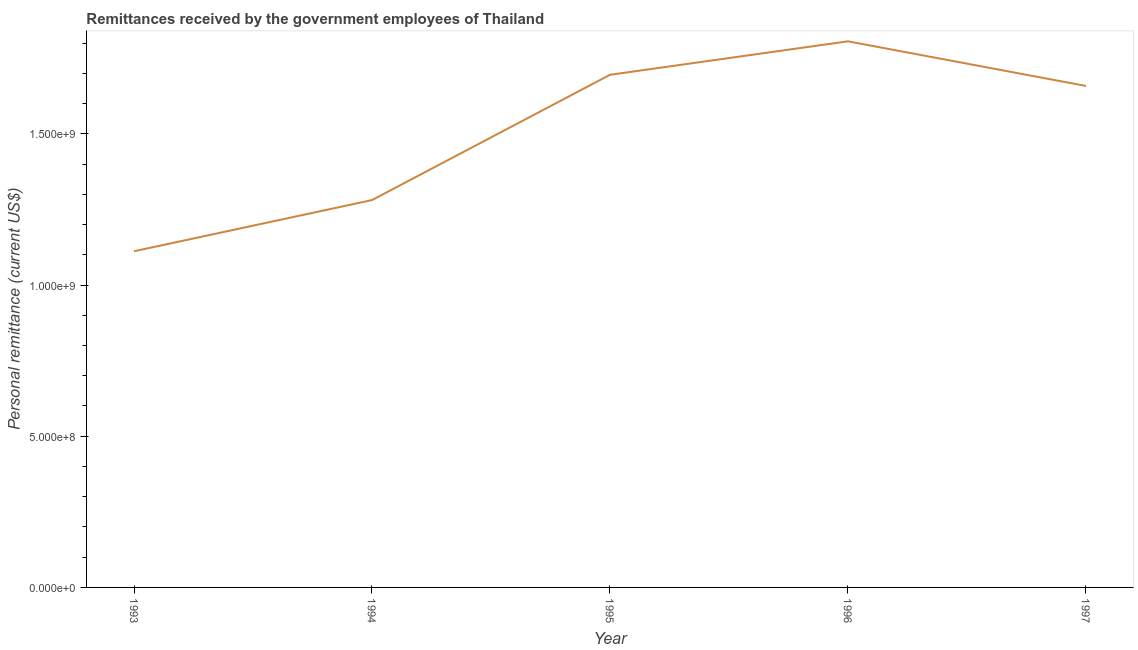What is the personal remittances in 1993?
Give a very brief answer. 1.11e+09. Across all years, what is the maximum personal remittances?
Keep it short and to the point. 1.81e+09. Across all years, what is the minimum personal remittances?
Provide a short and direct response. 1.11e+09. What is the sum of the personal remittances?
Keep it short and to the point. 7.55e+09. What is the difference between the personal remittances in 1994 and 1997?
Ensure brevity in your answer.  -3.77e+08. What is the average personal remittances per year?
Your answer should be very brief. 1.51e+09. What is the median personal remittances?
Give a very brief answer. 1.66e+09. In how many years, is the personal remittances greater than 700000000 US$?
Offer a very short reply. 5. What is the ratio of the personal remittances in 1995 to that in 1996?
Provide a succinct answer. 0.94. What is the difference between the highest and the second highest personal remittances?
Your answer should be very brief. 1.11e+08. Is the sum of the personal remittances in 1996 and 1997 greater than the maximum personal remittances across all years?
Your answer should be very brief. Yes. What is the difference between the highest and the lowest personal remittances?
Offer a very short reply. 6.94e+08. Does the personal remittances monotonically increase over the years?
Your answer should be compact. No. How many lines are there?
Your response must be concise. 1. Are the values on the major ticks of Y-axis written in scientific E-notation?
Make the answer very short. Yes. What is the title of the graph?
Your response must be concise. Remittances received by the government employees of Thailand. What is the label or title of the X-axis?
Provide a succinct answer. Year. What is the label or title of the Y-axis?
Offer a terse response. Personal remittance (current US$). What is the Personal remittance (current US$) of 1993?
Provide a short and direct response. 1.11e+09. What is the Personal remittance (current US$) in 1994?
Provide a short and direct response. 1.28e+09. What is the Personal remittance (current US$) of 1995?
Your answer should be compact. 1.70e+09. What is the Personal remittance (current US$) in 1996?
Give a very brief answer. 1.81e+09. What is the Personal remittance (current US$) of 1997?
Offer a terse response. 1.66e+09. What is the difference between the Personal remittance (current US$) in 1993 and 1994?
Ensure brevity in your answer.  -1.69e+08. What is the difference between the Personal remittance (current US$) in 1993 and 1995?
Your answer should be compact. -5.84e+08. What is the difference between the Personal remittance (current US$) in 1993 and 1996?
Provide a short and direct response. -6.94e+08. What is the difference between the Personal remittance (current US$) in 1993 and 1997?
Ensure brevity in your answer.  -5.47e+08. What is the difference between the Personal remittance (current US$) in 1994 and 1995?
Provide a short and direct response. -4.14e+08. What is the difference between the Personal remittance (current US$) in 1994 and 1996?
Keep it short and to the point. -5.25e+08. What is the difference between the Personal remittance (current US$) in 1994 and 1997?
Your answer should be very brief. -3.77e+08. What is the difference between the Personal remittance (current US$) in 1995 and 1996?
Make the answer very short. -1.11e+08. What is the difference between the Personal remittance (current US$) in 1995 and 1997?
Your response must be concise. 3.69e+07. What is the difference between the Personal remittance (current US$) in 1996 and 1997?
Your answer should be compact. 1.48e+08. What is the ratio of the Personal remittance (current US$) in 1993 to that in 1994?
Offer a very short reply. 0.87. What is the ratio of the Personal remittance (current US$) in 1993 to that in 1995?
Make the answer very short. 0.66. What is the ratio of the Personal remittance (current US$) in 1993 to that in 1996?
Provide a short and direct response. 0.62. What is the ratio of the Personal remittance (current US$) in 1993 to that in 1997?
Your response must be concise. 0.67. What is the ratio of the Personal remittance (current US$) in 1994 to that in 1995?
Your answer should be very brief. 0.76. What is the ratio of the Personal remittance (current US$) in 1994 to that in 1996?
Keep it short and to the point. 0.71. What is the ratio of the Personal remittance (current US$) in 1994 to that in 1997?
Provide a short and direct response. 0.77. What is the ratio of the Personal remittance (current US$) in 1995 to that in 1996?
Keep it short and to the point. 0.94. What is the ratio of the Personal remittance (current US$) in 1996 to that in 1997?
Ensure brevity in your answer.  1.09. 